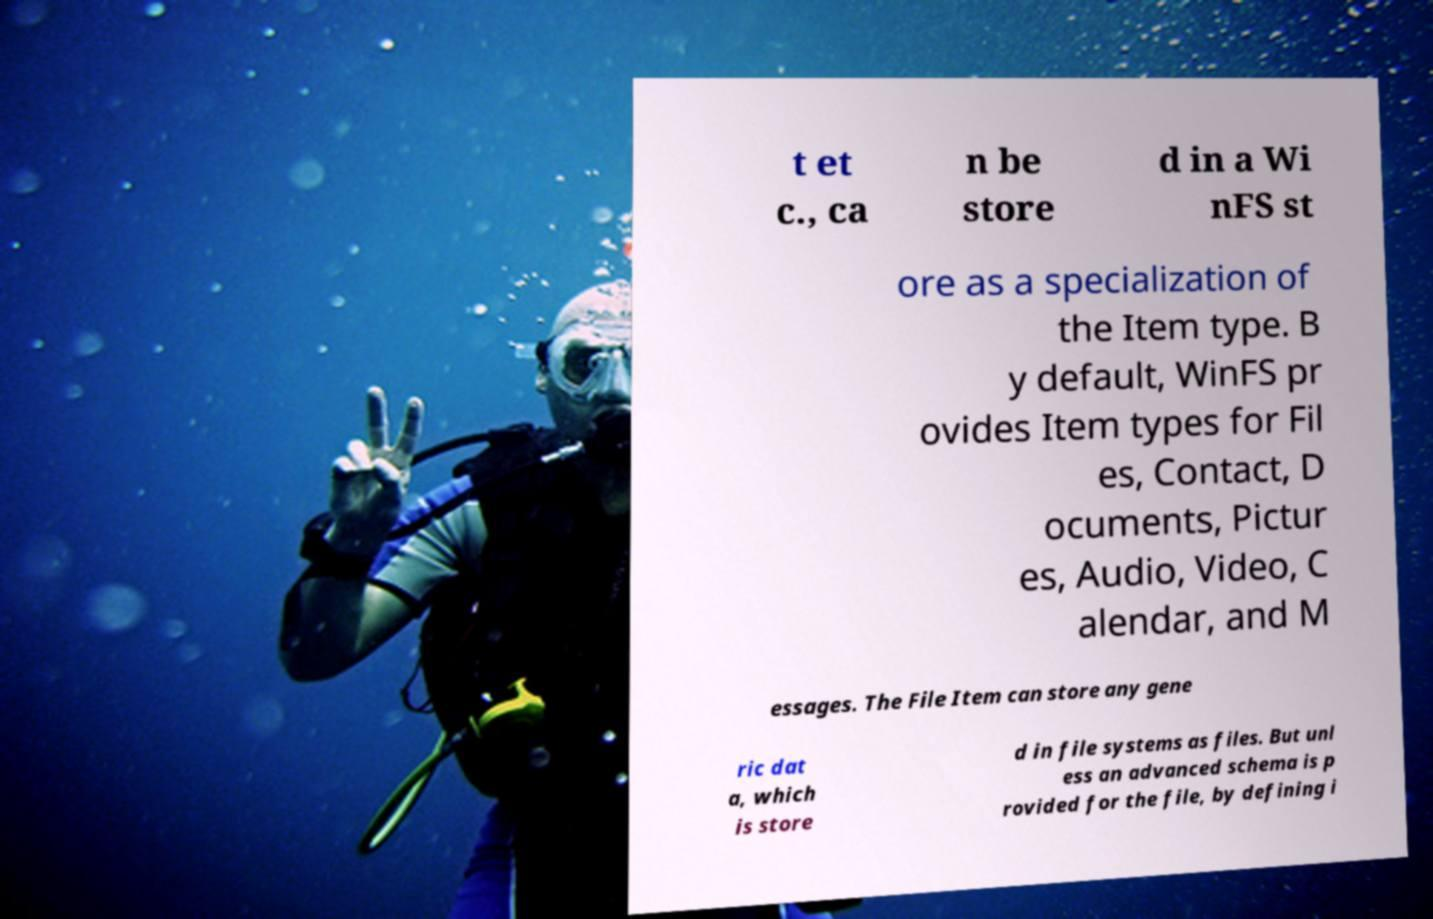Can you accurately transcribe the text from the provided image for me? t et c., ca n be store d in a Wi nFS st ore as a specialization of the Item type. B y default, WinFS pr ovides Item types for Fil es, Contact, D ocuments, Pictur es, Audio, Video, C alendar, and M essages. The File Item can store any gene ric dat a, which is store d in file systems as files. But unl ess an advanced schema is p rovided for the file, by defining i 